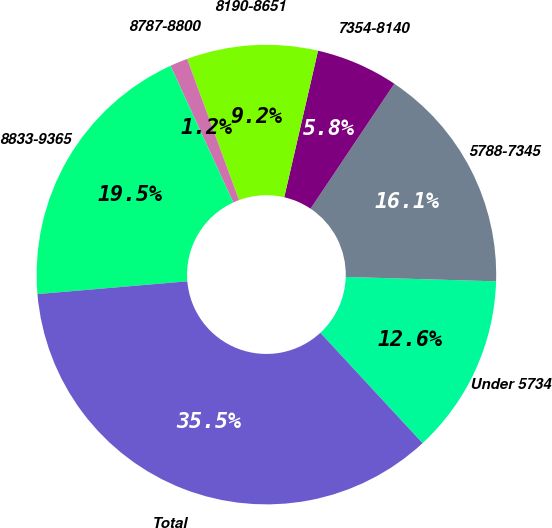Convert chart to OTSL. <chart><loc_0><loc_0><loc_500><loc_500><pie_chart><fcel>Under 5734<fcel>5788-7345<fcel>7354-8140<fcel>8190-8651<fcel>8787-8800<fcel>8833-9365<fcel>Total<nl><fcel>12.64%<fcel>16.07%<fcel>5.79%<fcel>9.21%<fcel>1.25%<fcel>19.5%<fcel>35.54%<nl></chart> 